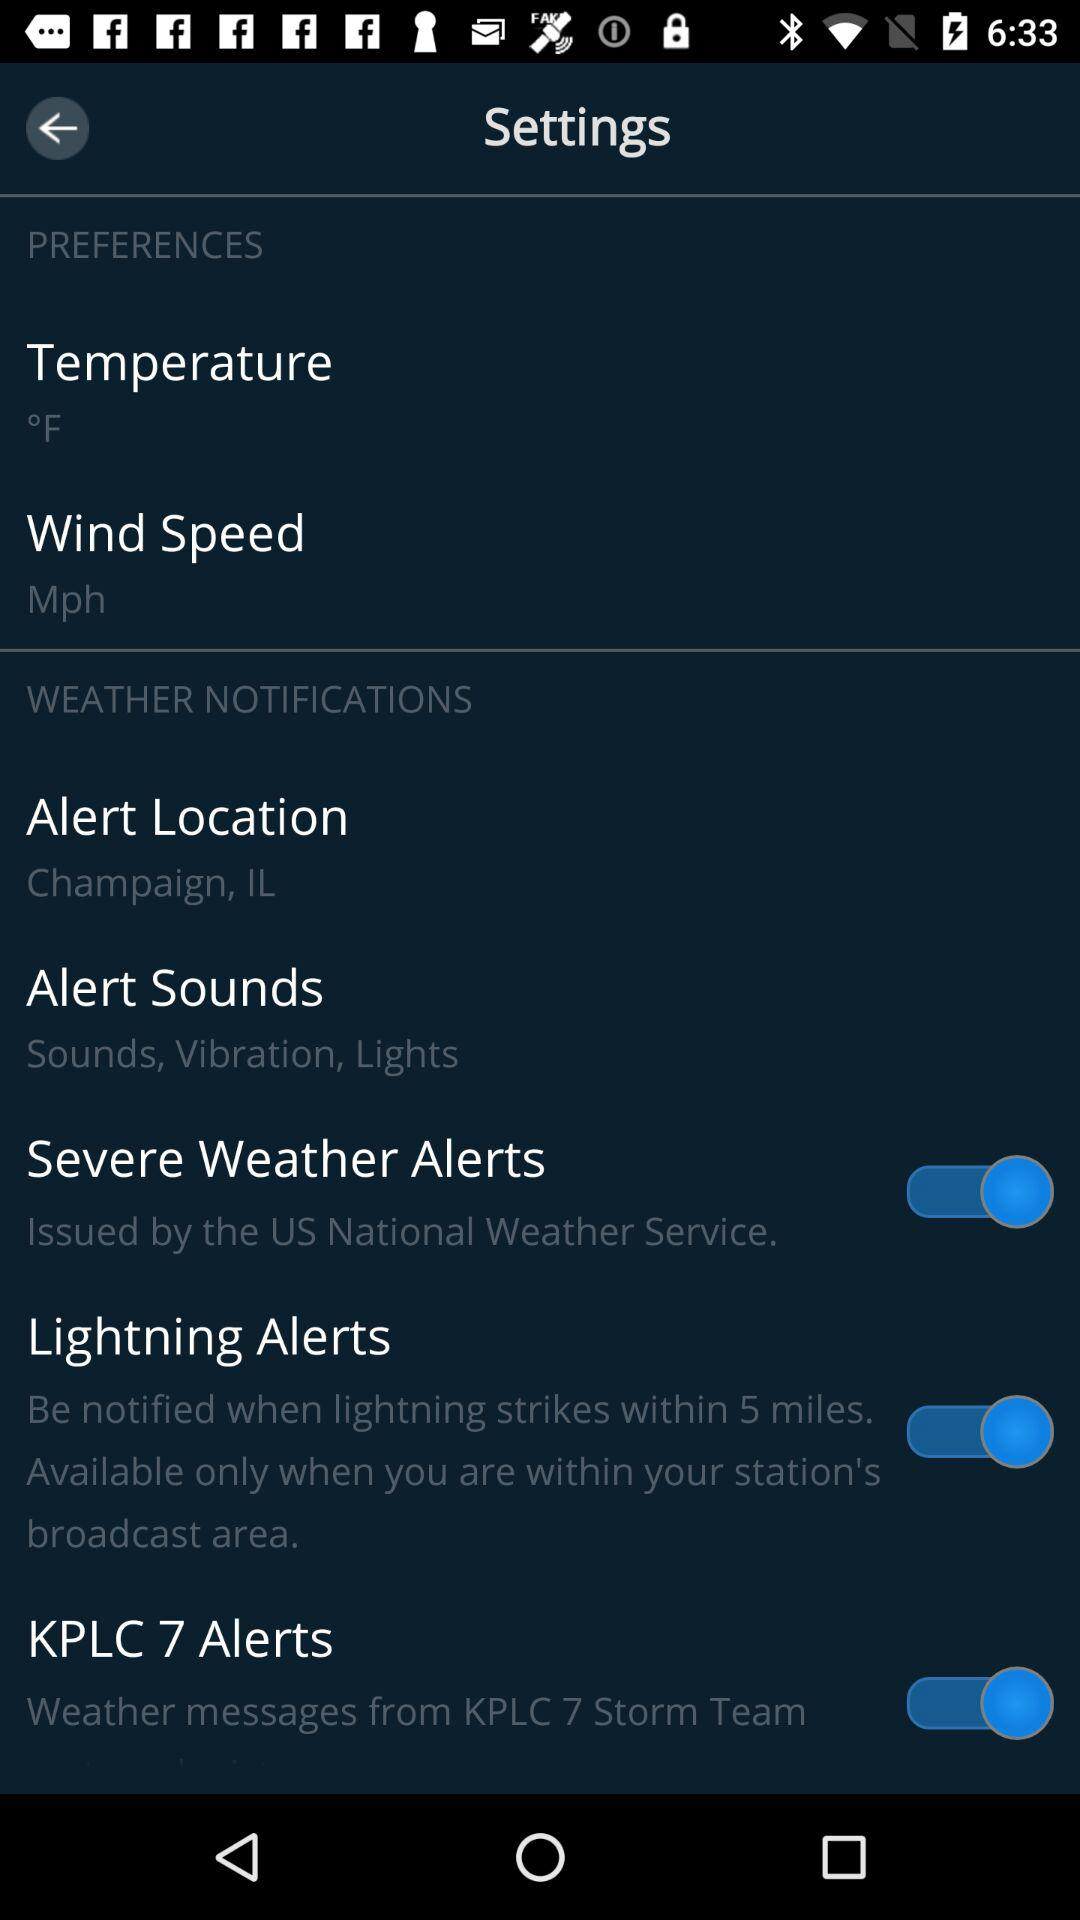What is the unit of temperature? The unit of temperature is °F. 